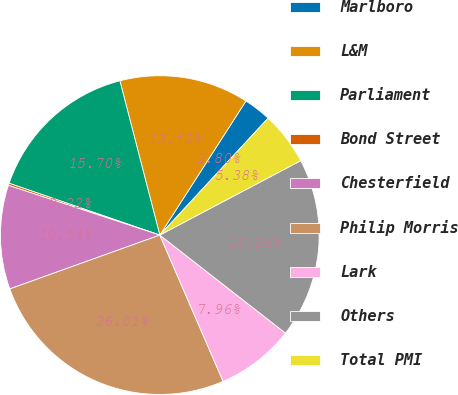<chart> <loc_0><loc_0><loc_500><loc_500><pie_chart><fcel>Marlboro<fcel>L&M<fcel>Parliament<fcel>Bond Street<fcel>Chesterfield<fcel>Philip Morris<fcel>Lark<fcel>Others<fcel>Total PMI<nl><fcel>2.8%<fcel>13.12%<fcel>15.7%<fcel>0.22%<fcel>10.54%<fcel>26.02%<fcel>7.96%<fcel>18.28%<fcel>5.38%<nl></chart> 